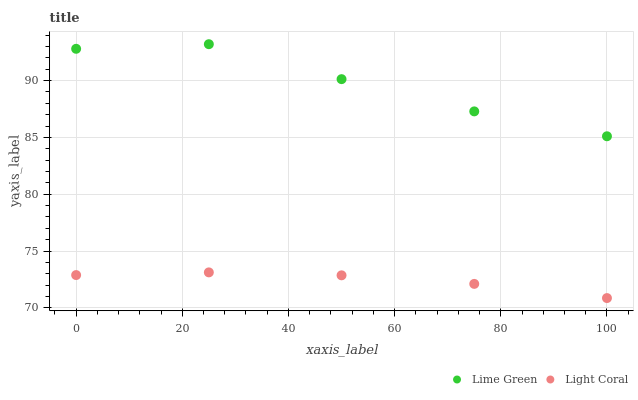Does Light Coral have the minimum area under the curve?
Answer yes or no. Yes. Does Lime Green have the maximum area under the curve?
Answer yes or no. Yes. Does Lime Green have the minimum area under the curve?
Answer yes or no. No. Is Light Coral the smoothest?
Answer yes or no. Yes. Is Lime Green the roughest?
Answer yes or no. Yes. Is Lime Green the smoothest?
Answer yes or no. No. Does Light Coral have the lowest value?
Answer yes or no. Yes. Does Lime Green have the lowest value?
Answer yes or no. No. Does Lime Green have the highest value?
Answer yes or no. Yes. Is Light Coral less than Lime Green?
Answer yes or no. Yes. Is Lime Green greater than Light Coral?
Answer yes or no. Yes. Does Light Coral intersect Lime Green?
Answer yes or no. No. 